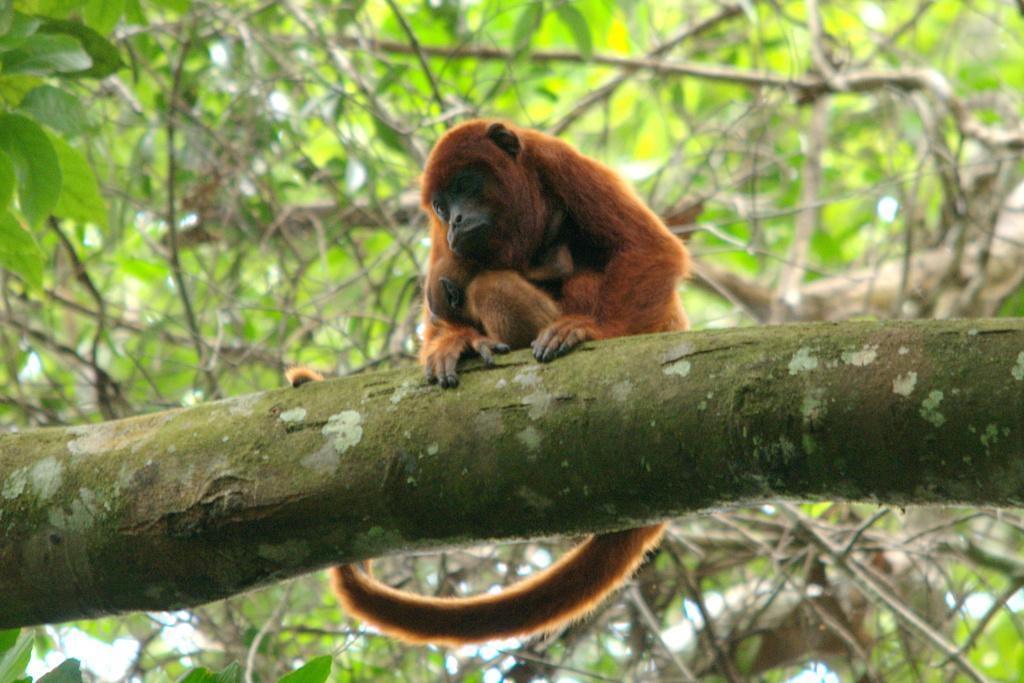Describe this image in one or two sentences. In this image I can see a money on the branch and the monkey is in brown color. Background I can see trees in green color. 